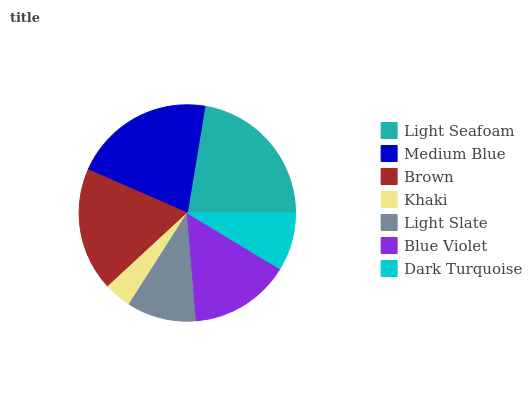Is Khaki the minimum?
Answer yes or no. Yes. Is Light Seafoam the maximum?
Answer yes or no. Yes. Is Medium Blue the minimum?
Answer yes or no. No. Is Medium Blue the maximum?
Answer yes or no. No. Is Light Seafoam greater than Medium Blue?
Answer yes or no. Yes. Is Medium Blue less than Light Seafoam?
Answer yes or no. Yes. Is Medium Blue greater than Light Seafoam?
Answer yes or no. No. Is Light Seafoam less than Medium Blue?
Answer yes or no. No. Is Blue Violet the high median?
Answer yes or no. Yes. Is Blue Violet the low median?
Answer yes or no. Yes. Is Dark Turquoise the high median?
Answer yes or no. No. Is Light Slate the low median?
Answer yes or no. No. 